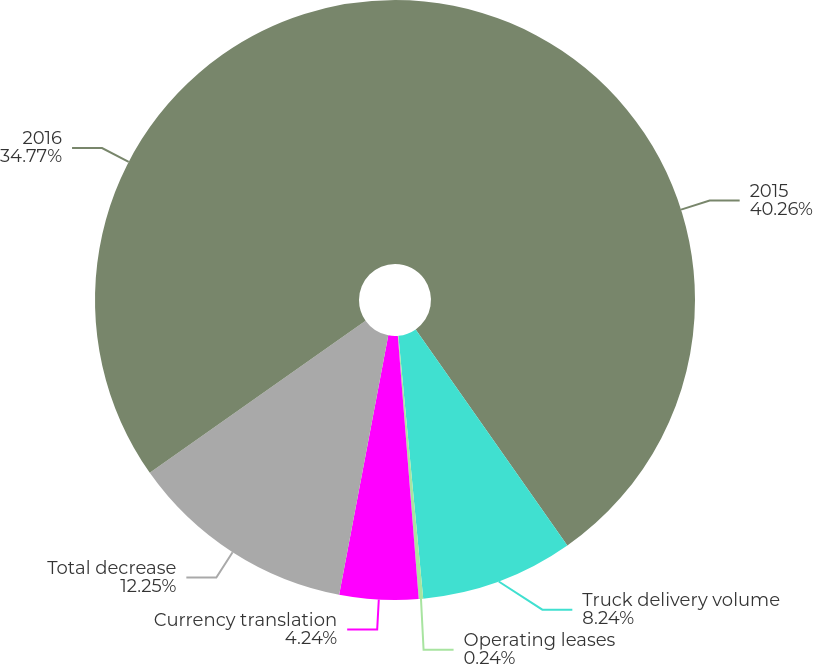<chart> <loc_0><loc_0><loc_500><loc_500><pie_chart><fcel>2015<fcel>Truck delivery volume<fcel>Operating leases<fcel>Currency translation<fcel>Total decrease<fcel>2016<nl><fcel>40.26%<fcel>8.24%<fcel>0.24%<fcel>4.24%<fcel>12.25%<fcel>34.77%<nl></chart> 